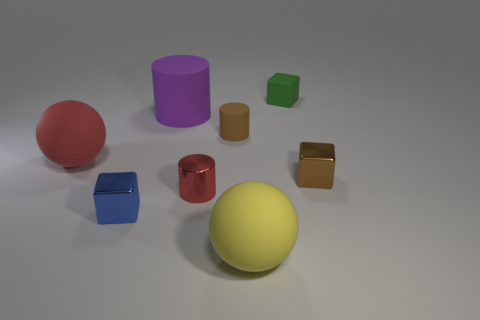Are the red cylinder and the big red object made of the same material?
Make the answer very short. No. There is another shiny object that is the same shape as the purple object; what is its size?
Keep it short and to the point. Small. There is a big thing that is on the right side of the small blue block and left of the yellow ball; what is it made of?
Give a very brief answer. Rubber. Is the number of shiny cylinders that are behind the small brown shiny object the same as the number of small green rubber blocks?
Make the answer very short. No. What number of things are matte spheres to the left of the purple thing or shiny things?
Make the answer very short. 4. There is a small metallic thing that is to the right of the small rubber cylinder; does it have the same color as the small rubber cylinder?
Provide a succinct answer. Yes. What size is the metallic thing that is on the right side of the brown rubber thing?
Offer a terse response. Small. What is the shape of the red object that is left of the metal object to the left of the red metallic object?
Offer a terse response. Sphere. What is the color of the other big object that is the same shape as the large yellow rubber object?
Ensure brevity in your answer.  Red. Do the brown thing to the right of the yellow matte thing and the small green cube have the same size?
Make the answer very short. Yes. 